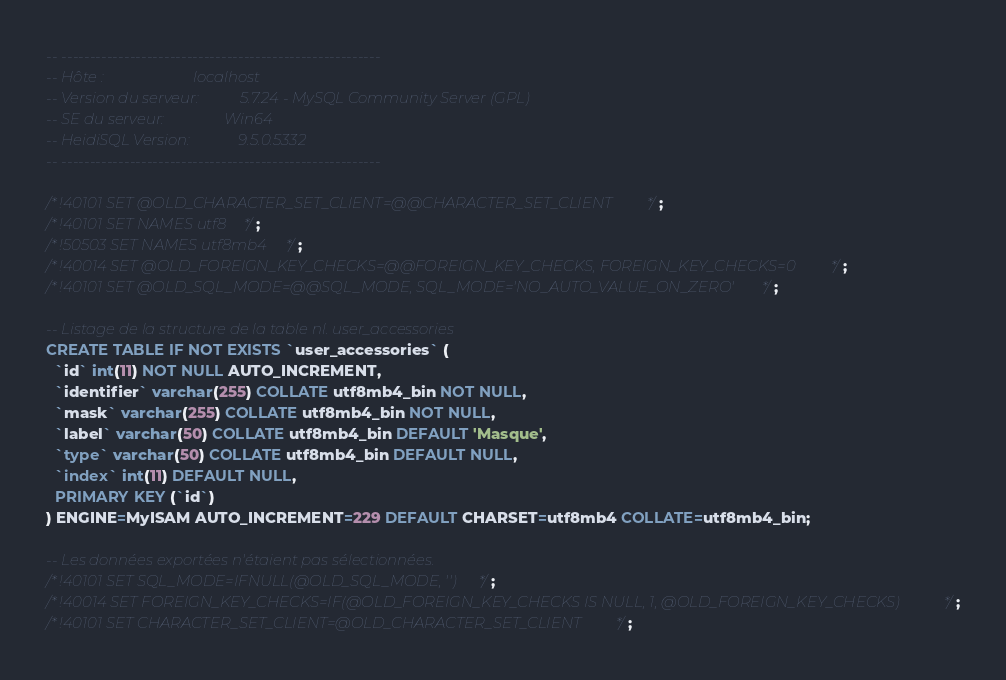<code> <loc_0><loc_0><loc_500><loc_500><_SQL_>-- --------------------------------------------------------
-- Hôte :                        localhost
-- Version du serveur:           5.7.24 - MySQL Community Server (GPL)
-- SE du serveur:                Win64
-- HeidiSQL Version:             9.5.0.5332
-- --------------------------------------------------------

/*!40101 SET @OLD_CHARACTER_SET_CLIENT=@@CHARACTER_SET_CLIENT */;
/*!40101 SET NAMES utf8 */;
/*!50503 SET NAMES utf8mb4 */;
/*!40014 SET @OLD_FOREIGN_KEY_CHECKS=@@FOREIGN_KEY_CHECKS, FOREIGN_KEY_CHECKS=0 */;
/*!40101 SET @OLD_SQL_MODE=@@SQL_MODE, SQL_MODE='NO_AUTO_VALUE_ON_ZERO' */;

-- Listage de la structure de la table nl. user_accessories
CREATE TABLE IF NOT EXISTS `user_accessories` (
  `id` int(11) NOT NULL AUTO_INCREMENT,
  `identifier` varchar(255) COLLATE utf8mb4_bin NOT NULL,
  `mask` varchar(255) COLLATE utf8mb4_bin NOT NULL,
  `label` varchar(50) COLLATE utf8mb4_bin DEFAULT 'Masque',
  `type` varchar(50) COLLATE utf8mb4_bin DEFAULT NULL,
  `index` int(11) DEFAULT NULL,
  PRIMARY KEY (`id`)
) ENGINE=MyISAM AUTO_INCREMENT=229 DEFAULT CHARSET=utf8mb4 COLLATE=utf8mb4_bin;

-- Les données exportées n'étaient pas sélectionnées.
/*!40101 SET SQL_MODE=IFNULL(@OLD_SQL_MODE, '') */;
/*!40014 SET FOREIGN_KEY_CHECKS=IF(@OLD_FOREIGN_KEY_CHECKS IS NULL, 1, @OLD_FOREIGN_KEY_CHECKS) */;
/*!40101 SET CHARACTER_SET_CLIENT=@OLD_CHARACTER_SET_CLIENT */;
</code> 